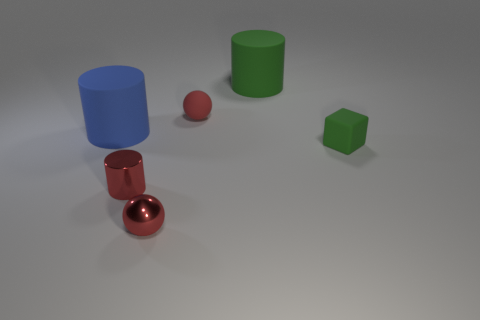Does the metallic cylinder have the same color as the tiny matte sphere?
Offer a terse response. Yes. There is a tiny matte sphere; is its color the same as the small sphere in front of the blue matte cylinder?
Provide a short and direct response. Yes. What number of large matte objects are the same color as the rubber cube?
Provide a succinct answer. 1. How many other matte things are the same shape as the blue object?
Provide a short and direct response. 1. Is there a tiny shiny thing of the same shape as the red matte thing?
Offer a terse response. Yes. There is a green cube that is the same size as the red matte thing; what is its material?
Your response must be concise. Rubber. Is the shape of the large blue matte object the same as the big green matte thing?
Your response must be concise. Yes. Is there anything else that is the same color as the small cylinder?
Provide a short and direct response. Yes. There is a large rubber cylinder on the right side of the small rubber thing behind the small green object; how many tiny rubber cubes are in front of it?
Offer a terse response. 1. Do the green rubber object that is to the left of the block and the blue thing have the same shape?
Your answer should be very brief. Yes. 